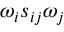<formula> <loc_0><loc_0><loc_500><loc_500>\omega _ { i } s _ { i j } \omega _ { j }</formula> 